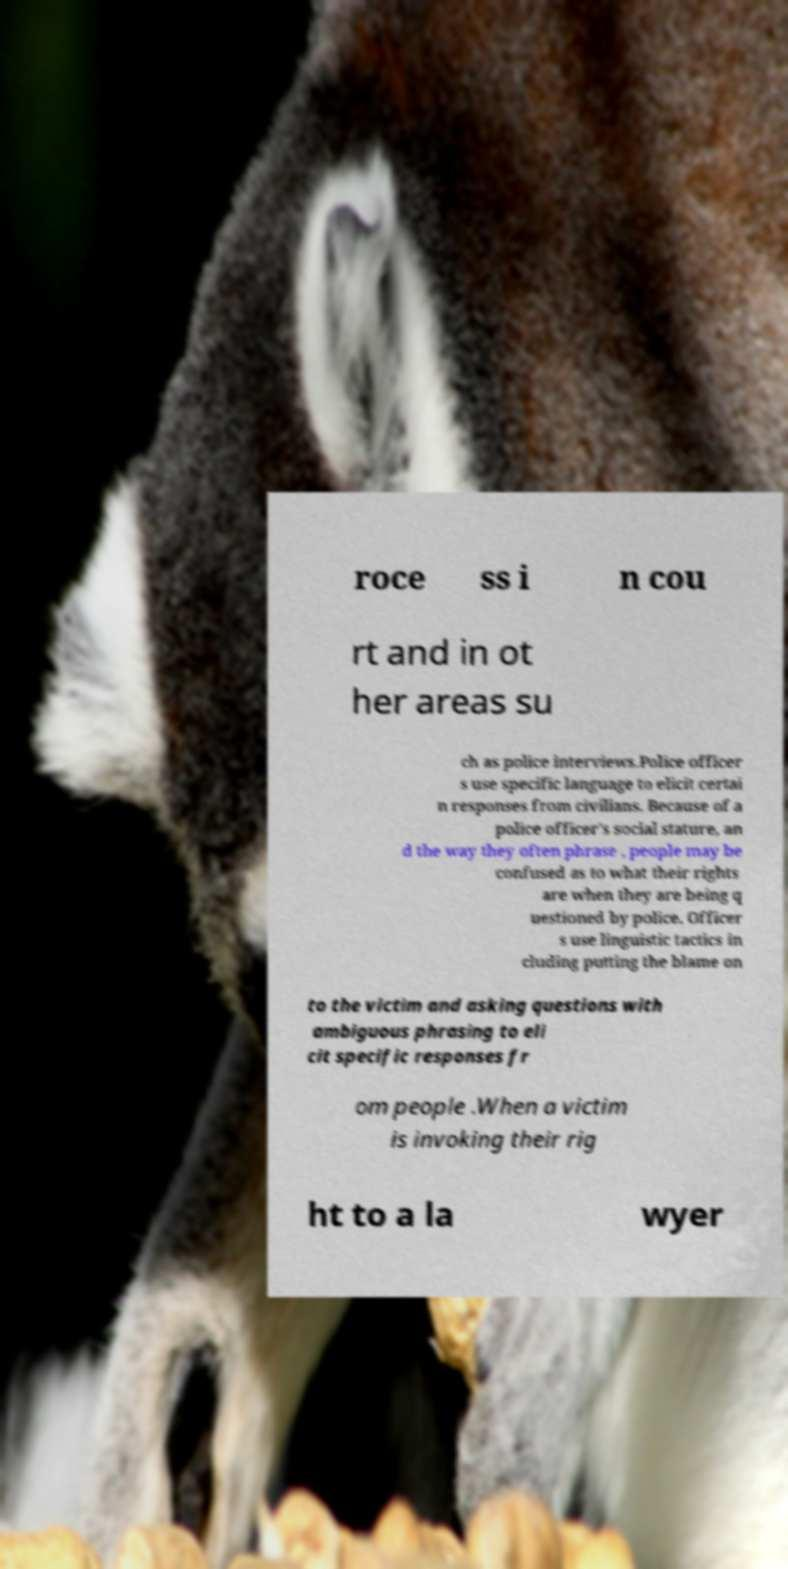Could you assist in decoding the text presented in this image and type it out clearly? roce ss i n cou rt and in ot her areas su ch as police interviews.Police officer s use specific language to elicit certai n responses from civilians. Because of a police officer's social stature, an d the way they often phrase , people may be confused as to what their rights are when they are being q uestioned by police. Officer s use linguistic tactics in cluding putting the blame on to the victim and asking questions with ambiguous phrasing to eli cit specific responses fr om people .When a victim is invoking their rig ht to a la wyer 